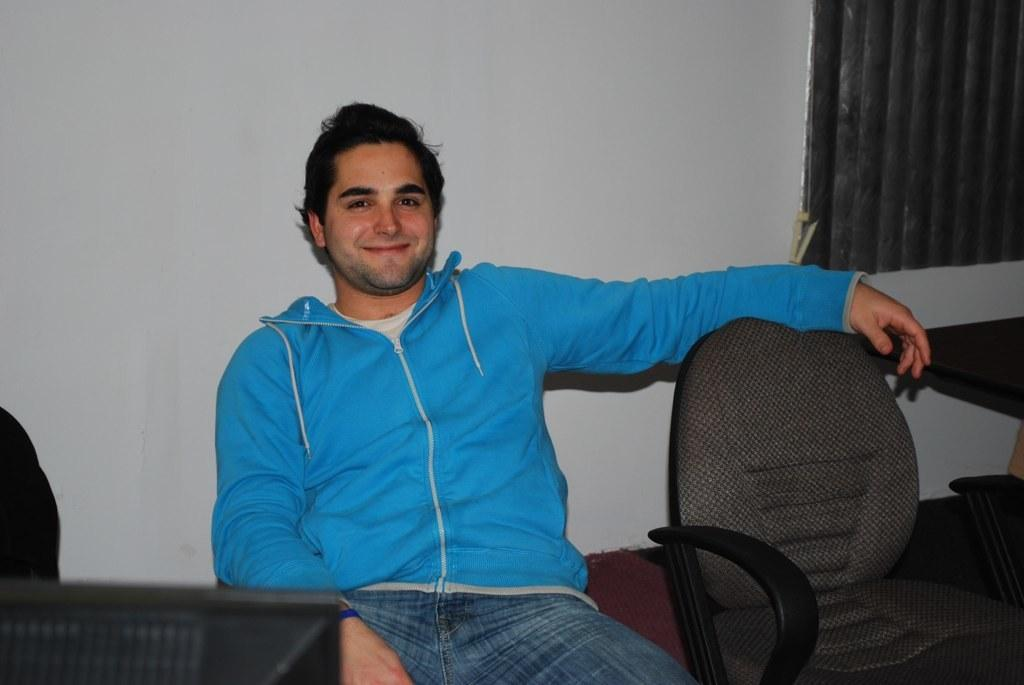What is the person in the image doing? The person is sitting on a chair in the image. How many chairs are visible in the image? There are two chairs visible in the image. What is the purpose of the table in the image? The table is likely used for placing objects or for other activities. What is the background of the image? There is a wall in the image, which serves as the background. What can be seen on the table or chairs in the image? There are objects visible on the table and chairs in the image. What type of brass instrument is being played in the image? There is no brass instrument or any musical instrument present in the image. 